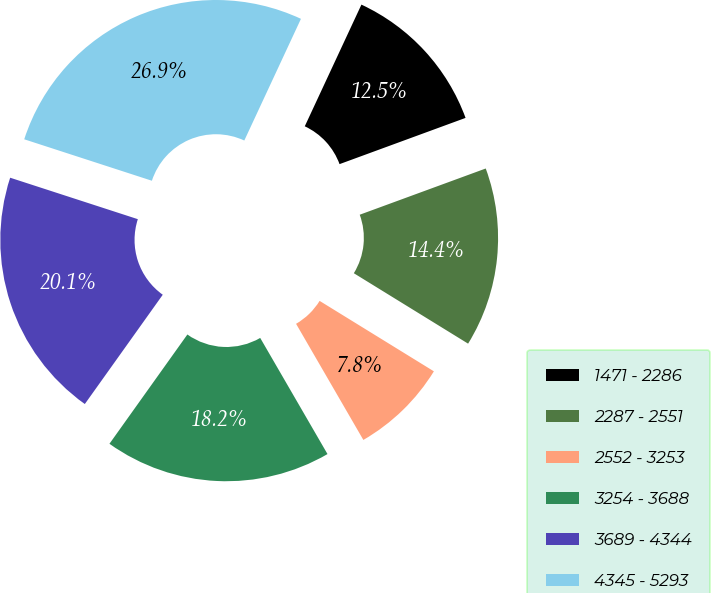Convert chart. <chart><loc_0><loc_0><loc_500><loc_500><pie_chart><fcel>1471 - 2286<fcel>2287 - 2551<fcel>2552 - 3253<fcel>3254 - 3688<fcel>3689 - 4344<fcel>4345 - 5293<nl><fcel>12.47%<fcel>14.39%<fcel>7.85%<fcel>18.22%<fcel>20.14%<fcel>26.94%<nl></chart> 